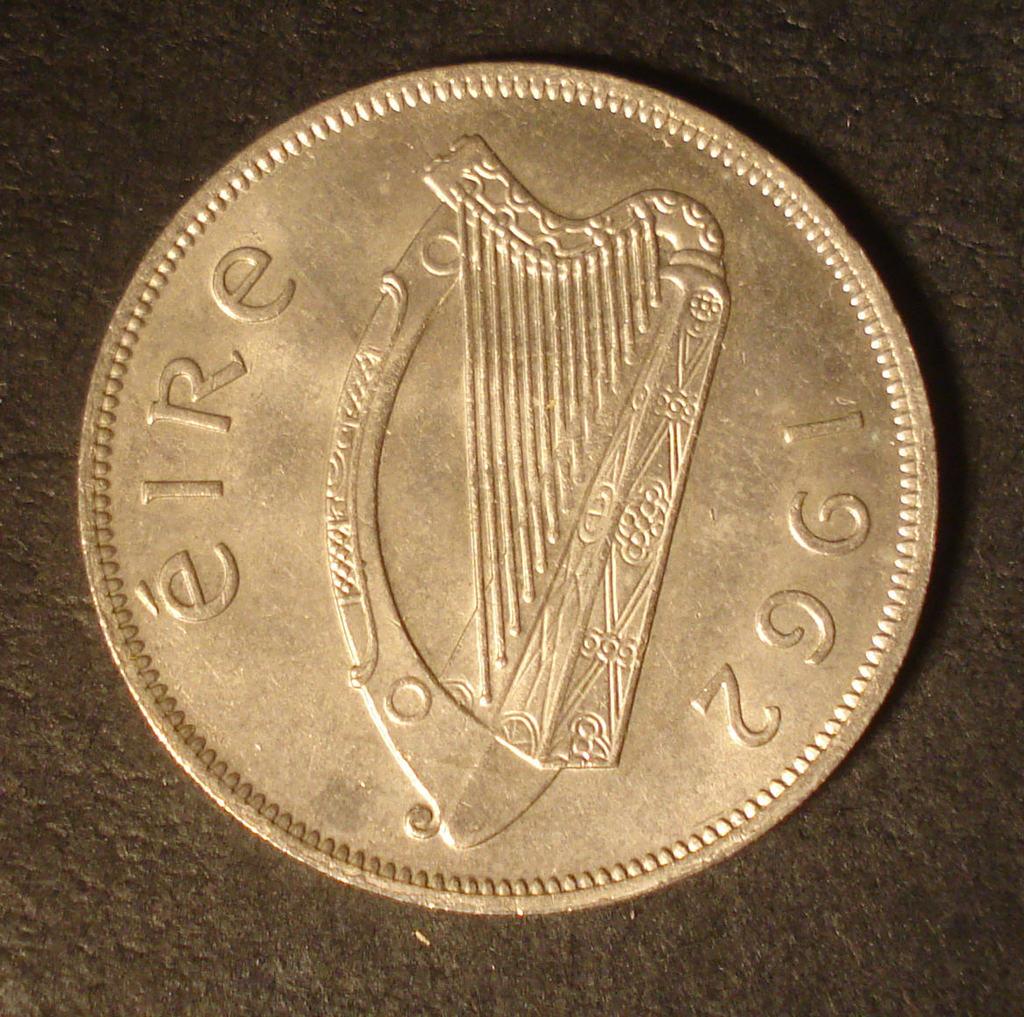What year was the coin minted?
Your response must be concise. 1962. 